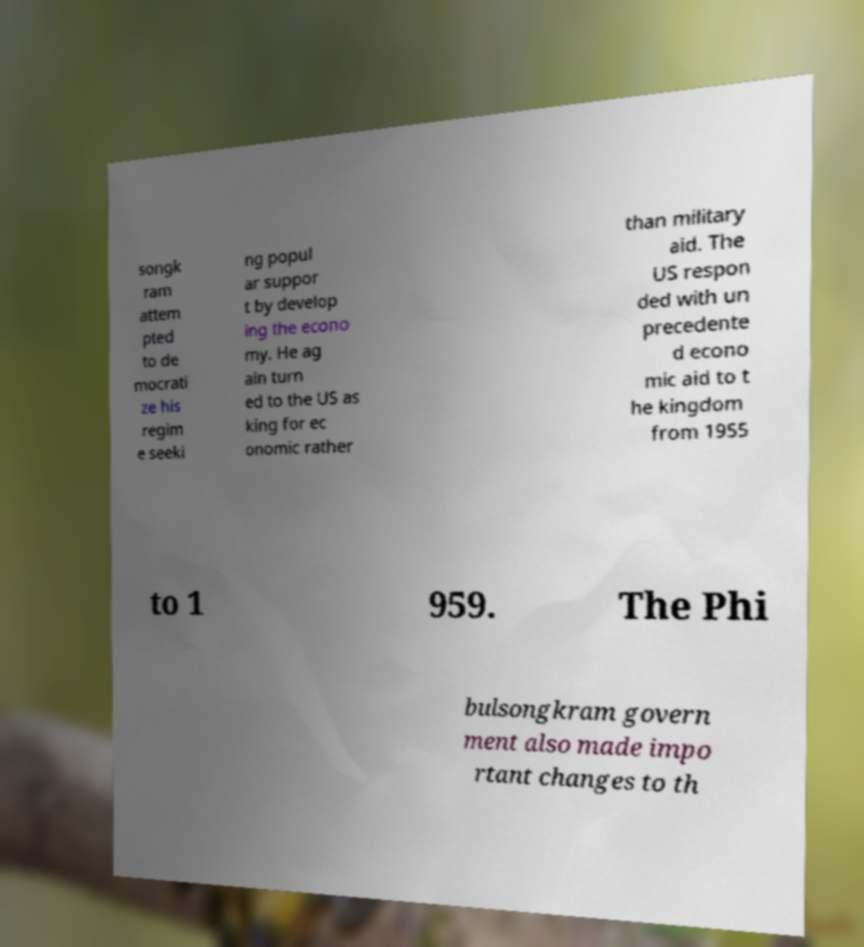There's text embedded in this image that I need extracted. Can you transcribe it verbatim? songk ram attem pted to de mocrati ze his regim e seeki ng popul ar suppor t by develop ing the econo my. He ag ain turn ed to the US as king for ec onomic rather than military aid. The US respon ded with un precedente d econo mic aid to t he kingdom from 1955 to 1 959. The Phi bulsongkram govern ment also made impo rtant changes to th 